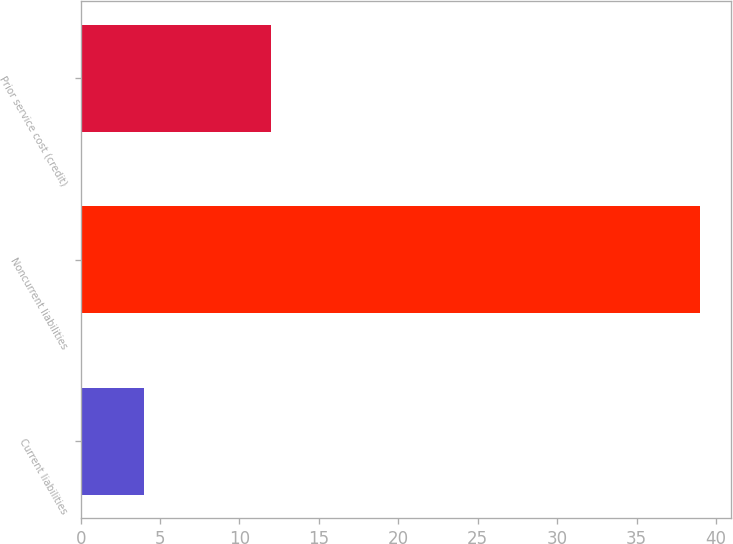<chart> <loc_0><loc_0><loc_500><loc_500><bar_chart><fcel>Current liabilities<fcel>Noncurrent liabilities<fcel>Prior service cost (credit)<nl><fcel>4<fcel>39<fcel>12<nl></chart> 